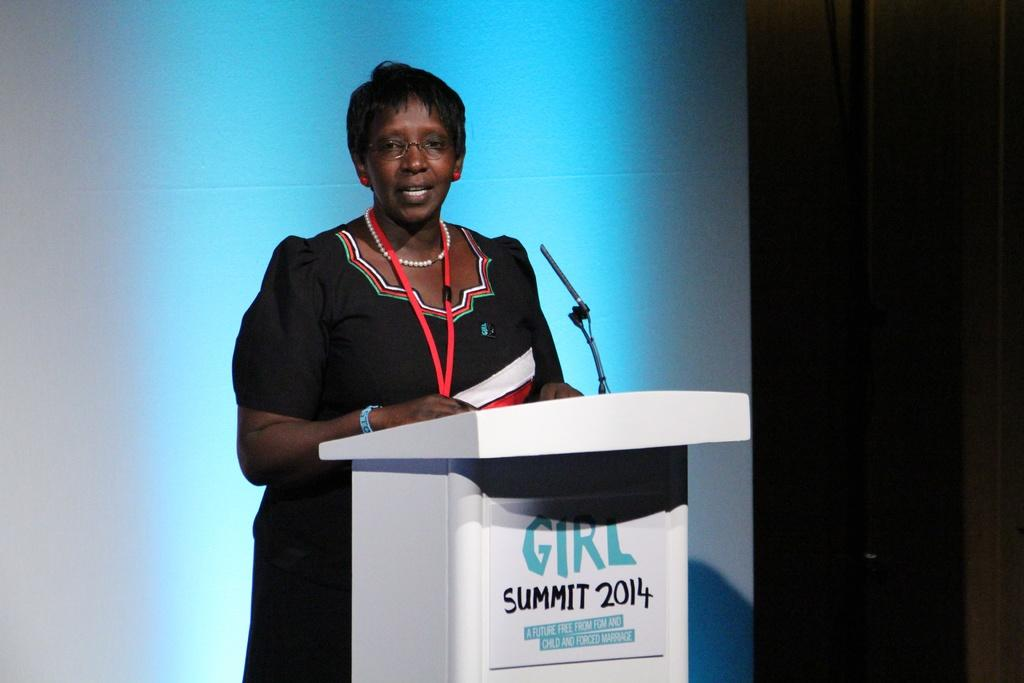Provide a one-sentence caption for the provided image. A woman speaks at the 2014 Girl Summit. 